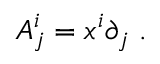<formula> <loc_0><loc_0><loc_500><loc_500>A _ { j } ^ { i } = x ^ { i } \partial _ { j } \, .</formula> 